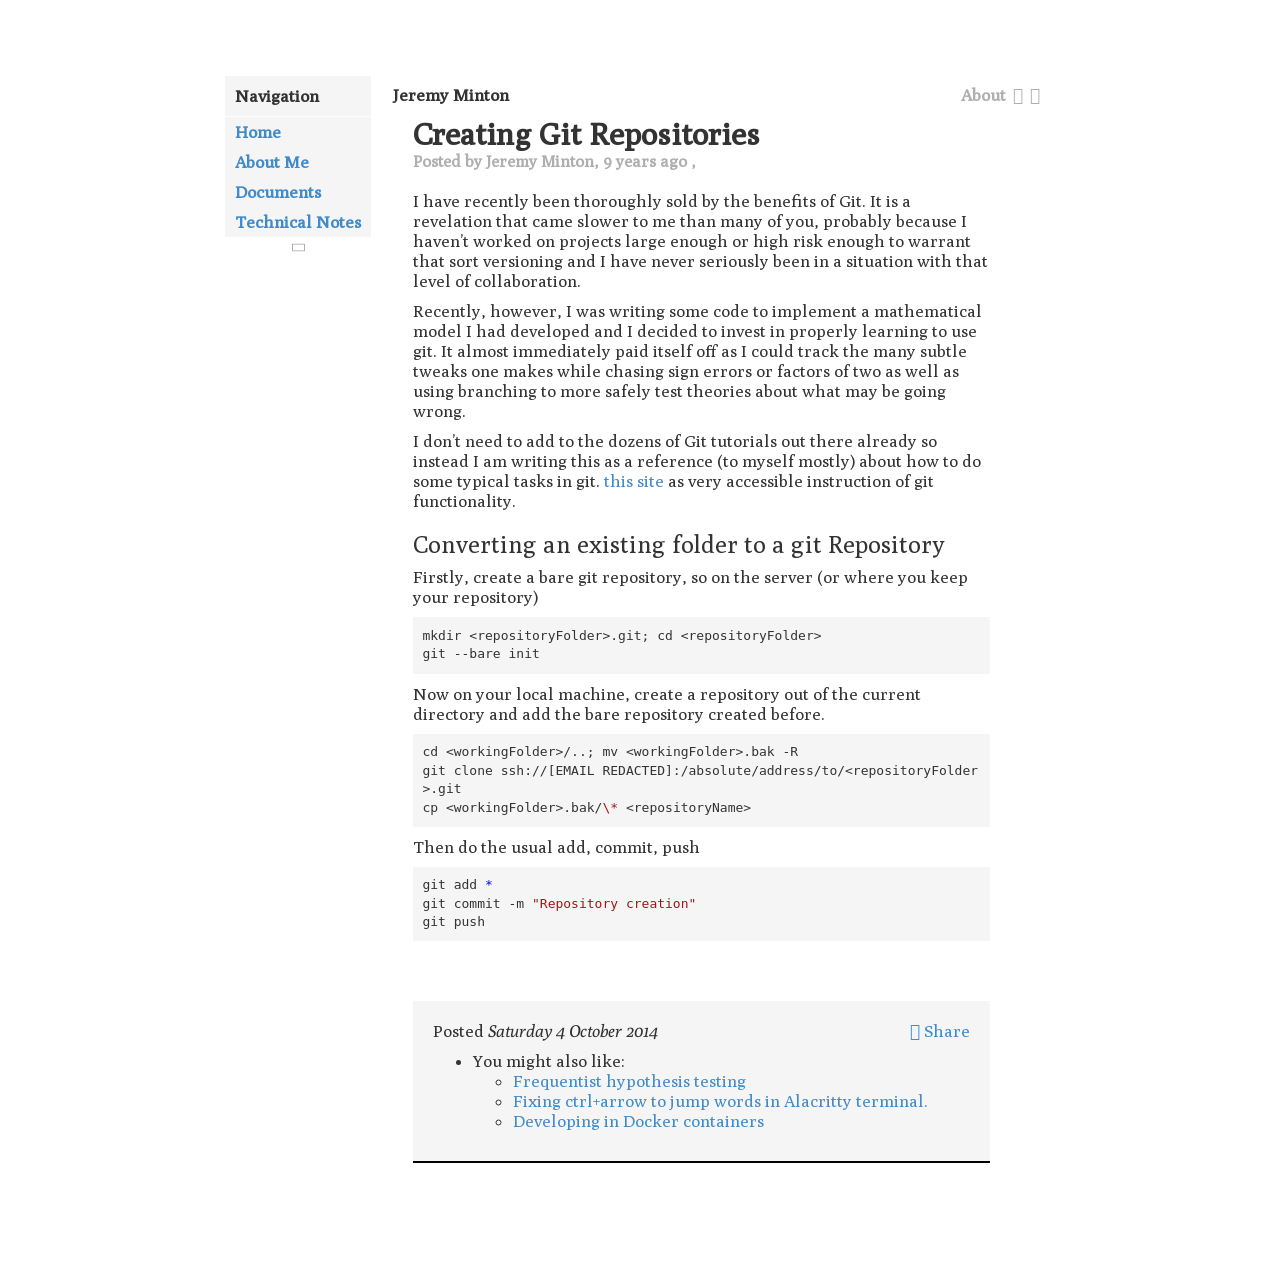Could you detail the process for assembling this website using HTML? To assemble a website like the one shown, which details creating Git repositories, using HTML, CSS, and possibly JavaScript is essential. Firstly, establish a clear structure with HTML, defining sections for navigation, content, and footer. Use CSS for styling, ensuring readability and easy navigation. Employ JavaScript for dynamic elements such as interactive menus. Be sure to keep accessibility in mind, making your website usable for everyone. 